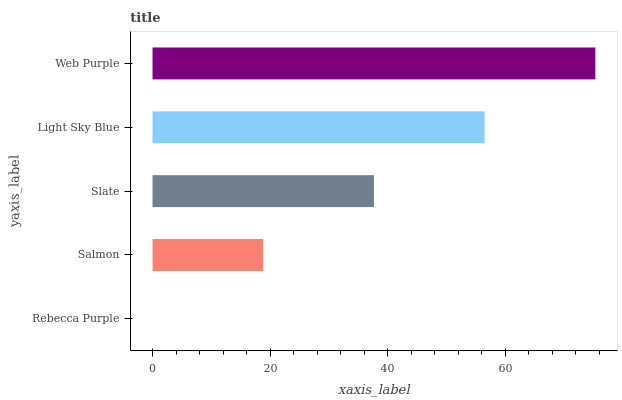Is Rebecca Purple the minimum?
Answer yes or no. Yes. Is Web Purple the maximum?
Answer yes or no. Yes. Is Salmon the minimum?
Answer yes or no. No. Is Salmon the maximum?
Answer yes or no. No. Is Salmon greater than Rebecca Purple?
Answer yes or no. Yes. Is Rebecca Purple less than Salmon?
Answer yes or no. Yes. Is Rebecca Purple greater than Salmon?
Answer yes or no. No. Is Salmon less than Rebecca Purple?
Answer yes or no. No. Is Slate the high median?
Answer yes or no. Yes. Is Slate the low median?
Answer yes or no. Yes. Is Salmon the high median?
Answer yes or no. No. Is Web Purple the low median?
Answer yes or no. No. 